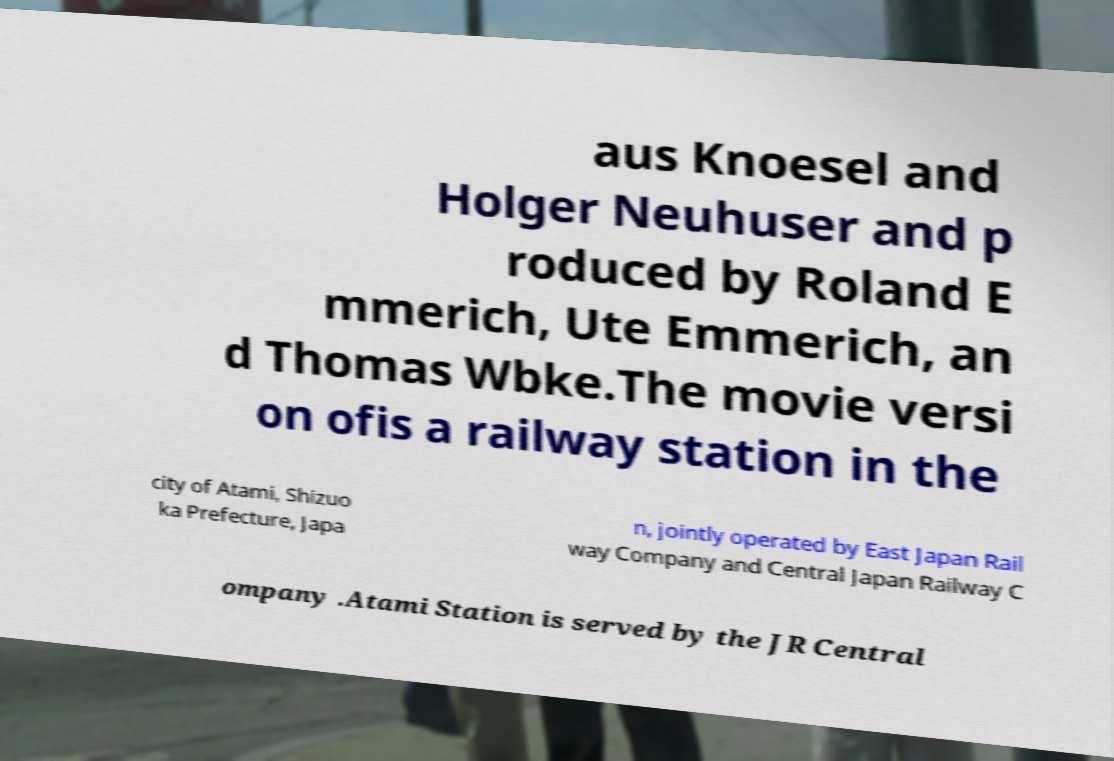Could you assist in decoding the text presented in this image and type it out clearly? aus Knoesel and Holger Neuhuser and p roduced by Roland E mmerich, Ute Emmerich, an d Thomas Wbke.The movie versi on ofis a railway station in the city of Atami, Shizuo ka Prefecture, Japa n, jointly operated by East Japan Rail way Company and Central Japan Railway C ompany .Atami Station is served by the JR Central 